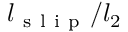Convert formula to latex. <formula><loc_0><loc_0><loc_500><loc_500>l _ { s l i p } / l _ { 2 }</formula> 